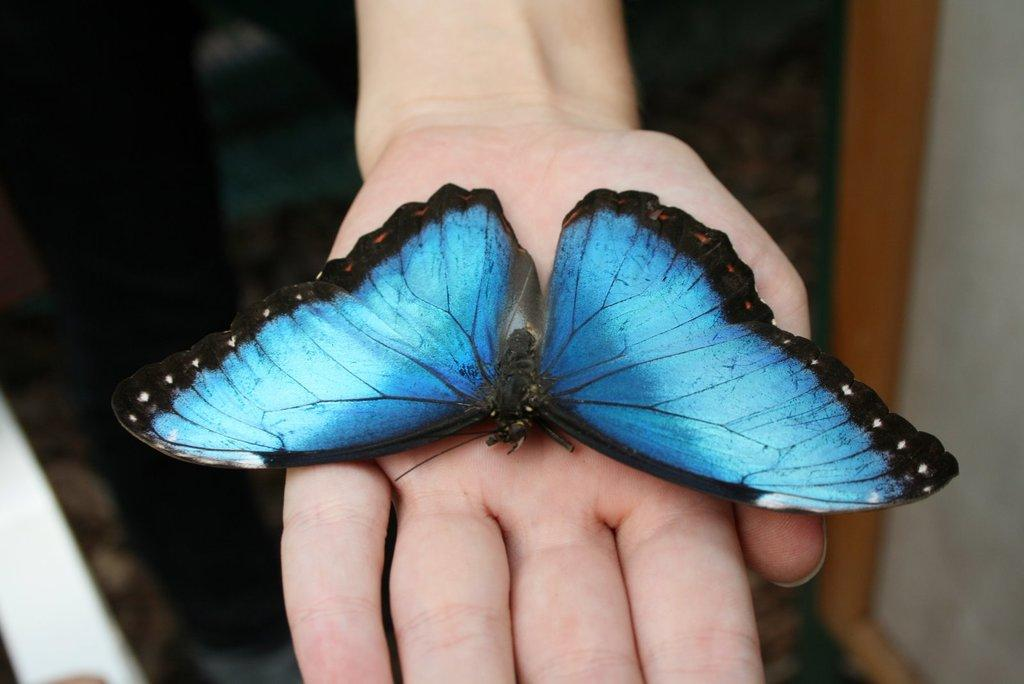What is the main subject of the image? There is a butterfly in the image. Where is the butterfly located? The butterfly is on a person's hand. What colors can be seen on the butterfly? The butterfly has blue and black colors. What role does the moon play in the image? The moon is not present in the image, so it does not play any role. 